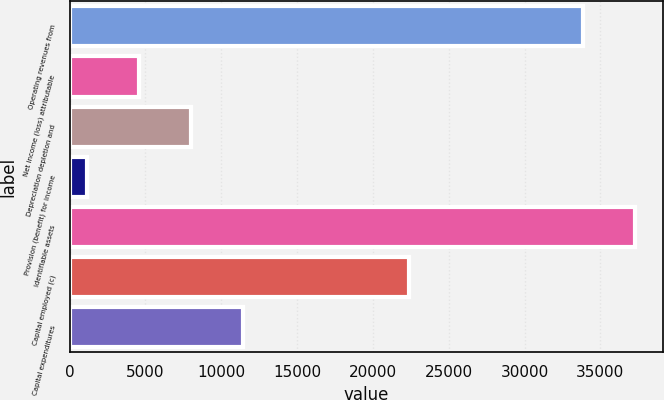<chart> <loc_0><loc_0><loc_500><loc_500><bar_chart><fcel>Operating revenues from<fcel>Net income (loss) attributable<fcel>Depreciation depletion and<fcel>Provision (benefit) for income<fcel>Identifiable assets<fcel>Capital employed (c)<fcel>Capital expenditures<nl><fcel>33862<fcel>4595.3<fcel>8017.6<fcel>1173<fcel>37284.3<fcel>22392<fcel>11439.9<nl></chart> 